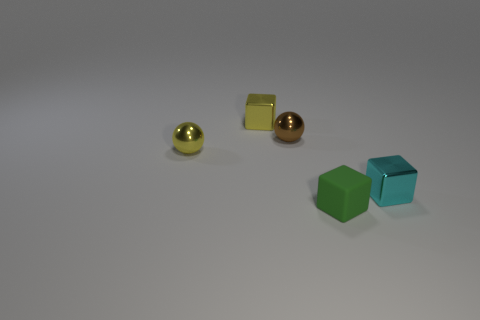Add 1 small brown metal spheres. How many objects exist? 6 Subtract all spheres. How many objects are left? 3 Add 5 small cyan shiny objects. How many small cyan shiny objects are left? 6 Add 1 large cyan spheres. How many large cyan spheres exist? 1 Subtract 0 cyan cylinders. How many objects are left? 5 Subtract all large cyan matte spheres. Subtract all yellow metal cubes. How many objects are left? 4 